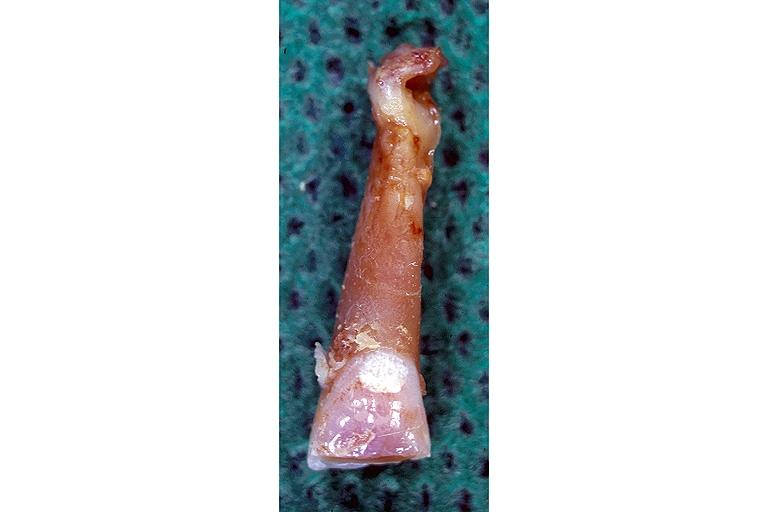what does this image show?
Answer the question using a single word or phrase. Attrition 